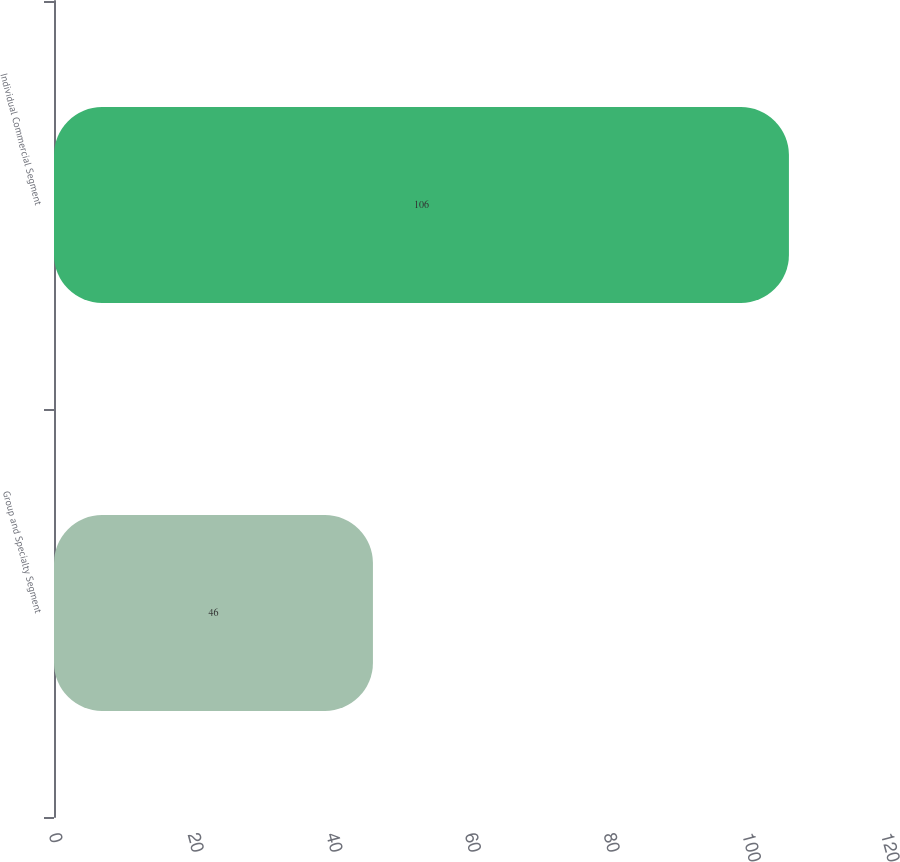Convert chart to OTSL. <chart><loc_0><loc_0><loc_500><loc_500><bar_chart><fcel>Group and Specialty Segment<fcel>Individual Commercial Segment<nl><fcel>46<fcel>106<nl></chart> 